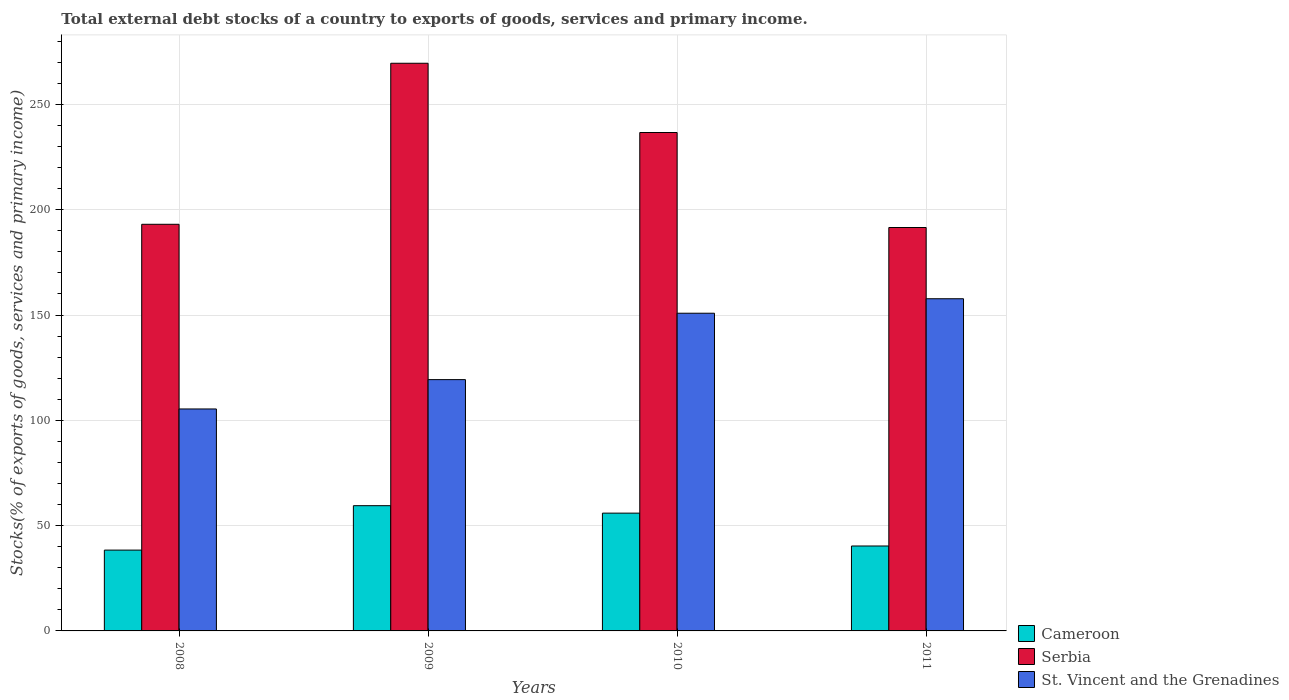How many groups of bars are there?
Your answer should be very brief. 4. Are the number of bars on each tick of the X-axis equal?
Provide a short and direct response. Yes. How many bars are there on the 2nd tick from the left?
Offer a very short reply. 3. What is the total debt stocks in Serbia in 2011?
Provide a short and direct response. 191.56. Across all years, what is the maximum total debt stocks in St. Vincent and the Grenadines?
Keep it short and to the point. 157.74. Across all years, what is the minimum total debt stocks in St. Vincent and the Grenadines?
Offer a very short reply. 105.4. In which year was the total debt stocks in St. Vincent and the Grenadines maximum?
Make the answer very short. 2011. What is the total total debt stocks in Cameroon in the graph?
Provide a short and direct response. 194.1. What is the difference between the total debt stocks in St. Vincent and the Grenadines in 2008 and that in 2010?
Make the answer very short. -45.46. What is the difference between the total debt stocks in St. Vincent and the Grenadines in 2008 and the total debt stocks in Cameroon in 2010?
Offer a very short reply. 49.47. What is the average total debt stocks in St. Vincent and the Grenadines per year?
Provide a succinct answer. 133.33. In the year 2008, what is the difference between the total debt stocks in Serbia and total debt stocks in Cameroon?
Your answer should be very brief. 154.71. What is the ratio of the total debt stocks in Cameroon in 2010 to that in 2011?
Give a very brief answer. 1.39. What is the difference between the highest and the second highest total debt stocks in Serbia?
Make the answer very short. 32.89. What is the difference between the highest and the lowest total debt stocks in Cameroon?
Your response must be concise. 21.09. What does the 1st bar from the left in 2009 represents?
Give a very brief answer. Cameroon. What does the 2nd bar from the right in 2008 represents?
Ensure brevity in your answer.  Serbia. Is it the case that in every year, the sum of the total debt stocks in Cameroon and total debt stocks in Serbia is greater than the total debt stocks in St. Vincent and the Grenadines?
Offer a terse response. Yes. How many bars are there?
Offer a terse response. 12. What is the difference between two consecutive major ticks on the Y-axis?
Offer a very short reply. 50. Are the values on the major ticks of Y-axis written in scientific E-notation?
Keep it short and to the point. No. Does the graph contain grids?
Keep it short and to the point. Yes. Where does the legend appear in the graph?
Your response must be concise. Bottom right. How many legend labels are there?
Provide a short and direct response. 3. What is the title of the graph?
Offer a terse response. Total external debt stocks of a country to exports of goods, services and primary income. Does "Kazakhstan" appear as one of the legend labels in the graph?
Your answer should be very brief. No. What is the label or title of the X-axis?
Give a very brief answer. Years. What is the label or title of the Y-axis?
Offer a terse response. Stocks(% of exports of goods, services and primary income). What is the Stocks(% of exports of goods, services and primary income) of Cameroon in 2008?
Your answer should be compact. 38.38. What is the Stocks(% of exports of goods, services and primary income) of Serbia in 2008?
Make the answer very short. 193.09. What is the Stocks(% of exports of goods, services and primary income) in St. Vincent and the Grenadines in 2008?
Provide a short and direct response. 105.4. What is the Stocks(% of exports of goods, services and primary income) in Cameroon in 2009?
Your answer should be very brief. 59.47. What is the Stocks(% of exports of goods, services and primary income) of Serbia in 2009?
Your response must be concise. 269.55. What is the Stocks(% of exports of goods, services and primary income) in St. Vincent and the Grenadines in 2009?
Ensure brevity in your answer.  119.33. What is the Stocks(% of exports of goods, services and primary income) of Cameroon in 2010?
Your answer should be compact. 55.93. What is the Stocks(% of exports of goods, services and primary income) in Serbia in 2010?
Give a very brief answer. 236.67. What is the Stocks(% of exports of goods, services and primary income) in St. Vincent and the Grenadines in 2010?
Your answer should be very brief. 150.85. What is the Stocks(% of exports of goods, services and primary income) in Cameroon in 2011?
Offer a very short reply. 40.33. What is the Stocks(% of exports of goods, services and primary income) of Serbia in 2011?
Give a very brief answer. 191.56. What is the Stocks(% of exports of goods, services and primary income) of St. Vincent and the Grenadines in 2011?
Keep it short and to the point. 157.74. Across all years, what is the maximum Stocks(% of exports of goods, services and primary income) of Cameroon?
Ensure brevity in your answer.  59.47. Across all years, what is the maximum Stocks(% of exports of goods, services and primary income) in Serbia?
Ensure brevity in your answer.  269.55. Across all years, what is the maximum Stocks(% of exports of goods, services and primary income) in St. Vincent and the Grenadines?
Give a very brief answer. 157.74. Across all years, what is the minimum Stocks(% of exports of goods, services and primary income) in Cameroon?
Your response must be concise. 38.38. Across all years, what is the minimum Stocks(% of exports of goods, services and primary income) in Serbia?
Provide a short and direct response. 191.56. Across all years, what is the minimum Stocks(% of exports of goods, services and primary income) of St. Vincent and the Grenadines?
Ensure brevity in your answer.  105.4. What is the total Stocks(% of exports of goods, services and primary income) of Cameroon in the graph?
Your answer should be compact. 194.1. What is the total Stocks(% of exports of goods, services and primary income) in Serbia in the graph?
Ensure brevity in your answer.  890.87. What is the total Stocks(% of exports of goods, services and primary income) of St. Vincent and the Grenadines in the graph?
Provide a short and direct response. 533.32. What is the difference between the Stocks(% of exports of goods, services and primary income) in Cameroon in 2008 and that in 2009?
Ensure brevity in your answer.  -21.09. What is the difference between the Stocks(% of exports of goods, services and primary income) of Serbia in 2008 and that in 2009?
Your answer should be compact. -76.47. What is the difference between the Stocks(% of exports of goods, services and primary income) of St. Vincent and the Grenadines in 2008 and that in 2009?
Give a very brief answer. -13.93. What is the difference between the Stocks(% of exports of goods, services and primary income) of Cameroon in 2008 and that in 2010?
Make the answer very short. -17.55. What is the difference between the Stocks(% of exports of goods, services and primary income) in Serbia in 2008 and that in 2010?
Your answer should be compact. -43.58. What is the difference between the Stocks(% of exports of goods, services and primary income) of St. Vincent and the Grenadines in 2008 and that in 2010?
Your response must be concise. -45.46. What is the difference between the Stocks(% of exports of goods, services and primary income) in Cameroon in 2008 and that in 2011?
Your answer should be very brief. -1.95. What is the difference between the Stocks(% of exports of goods, services and primary income) in Serbia in 2008 and that in 2011?
Provide a short and direct response. 1.53. What is the difference between the Stocks(% of exports of goods, services and primary income) in St. Vincent and the Grenadines in 2008 and that in 2011?
Give a very brief answer. -52.34. What is the difference between the Stocks(% of exports of goods, services and primary income) in Cameroon in 2009 and that in 2010?
Your answer should be compact. 3.54. What is the difference between the Stocks(% of exports of goods, services and primary income) in Serbia in 2009 and that in 2010?
Give a very brief answer. 32.89. What is the difference between the Stocks(% of exports of goods, services and primary income) in St. Vincent and the Grenadines in 2009 and that in 2010?
Provide a short and direct response. -31.52. What is the difference between the Stocks(% of exports of goods, services and primary income) in Cameroon in 2009 and that in 2011?
Give a very brief answer. 19.14. What is the difference between the Stocks(% of exports of goods, services and primary income) of Serbia in 2009 and that in 2011?
Provide a short and direct response. 77.99. What is the difference between the Stocks(% of exports of goods, services and primary income) in St. Vincent and the Grenadines in 2009 and that in 2011?
Provide a short and direct response. -38.41. What is the difference between the Stocks(% of exports of goods, services and primary income) in Cameroon in 2010 and that in 2011?
Offer a terse response. 15.6. What is the difference between the Stocks(% of exports of goods, services and primary income) in Serbia in 2010 and that in 2011?
Make the answer very short. 45.11. What is the difference between the Stocks(% of exports of goods, services and primary income) in St. Vincent and the Grenadines in 2010 and that in 2011?
Offer a terse response. -6.88. What is the difference between the Stocks(% of exports of goods, services and primary income) of Cameroon in 2008 and the Stocks(% of exports of goods, services and primary income) of Serbia in 2009?
Your answer should be compact. -231.18. What is the difference between the Stocks(% of exports of goods, services and primary income) of Cameroon in 2008 and the Stocks(% of exports of goods, services and primary income) of St. Vincent and the Grenadines in 2009?
Offer a terse response. -80.95. What is the difference between the Stocks(% of exports of goods, services and primary income) in Serbia in 2008 and the Stocks(% of exports of goods, services and primary income) in St. Vincent and the Grenadines in 2009?
Offer a terse response. 73.76. What is the difference between the Stocks(% of exports of goods, services and primary income) of Cameroon in 2008 and the Stocks(% of exports of goods, services and primary income) of Serbia in 2010?
Ensure brevity in your answer.  -198.29. What is the difference between the Stocks(% of exports of goods, services and primary income) of Cameroon in 2008 and the Stocks(% of exports of goods, services and primary income) of St. Vincent and the Grenadines in 2010?
Give a very brief answer. -112.48. What is the difference between the Stocks(% of exports of goods, services and primary income) in Serbia in 2008 and the Stocks(% of exports of goods, services and primary income) in St. Vincent and the Grenadines in 2010?
Offer a terse response. 42.23. What is the difference between the Stocks(% of exports of goods, services and primary income) in Cameroon in 2008 and the Stocks(% of exports of goods, services and primary income) in Serbia in 2011?
Offer a very short reply. -153.18. What is the difference between the Stocks(% of exports of goods, services and primary income) of Cameroon in 2008 and the Stocks(% of exports of goods, services and primary income) of St. Vincent and the Grenadines in 2011?
Offer a very short reply. -119.36. What is the difference between the Stocks(% of exports of goods, services and primary income) in Serbia in 2008 and the Stocks(% of exports of goods, services and primary income) in St. Vincent and the Grenadines in 2011?
Your response must be concise. 35.35. What is the difference between the Stocks(% of exports of goods, services and primary income) of Cameroon in 2009 and the Stocks(% of exports of goods, services and primary income) of Serbia in 2010?
Provide a succinct answer. -177.2. What is the difference between the Stocks(% of exports of goods, services and primary income) of Cameroon in 2009 and the Stocks(% of exports of goods, services and primary income) of St. Vincent and the Grenadines in 2010?
Offer a terse response. -91.39. What is the difference between the Stocks(% of exports of goods, services and primary income) in Serbia in 2009 and the Stocks(% of exports of goods, services and primary income) in St. Vincent and the Grenadines in 2010?
Give a very brief answer. 118.7. What is the difference between the Stocks(% of exports of goods, services and primary income) of Cameroon in 2009 and the Stocks(% of exports of goods, services and primary income) of Serbia in 2011?
Make the answer very short. -132.09. What is the difference between the Stocks(% of exports of goods, services and primary income) in Cameroon in 2009 and the Stocks(% of exports of goods, services and primary income) in St. Vincent and the Grenadines in 2011?
Make the answer very short. -98.27. What is the difference between the Stocks(% of exports of goods, services and primary income) in Serbia in 2009 and the Stocks(% of exports of goods, services and primary income) in St. Vincent and the Grenadines in 2011?
Offer a very short reply. 111.82. What is the difference between the Stocks(% of exports of goods, services and primary income) in Cameroon in 2010 and the Stocks(% of exports of goods, services and primary income) in Serbia in 2011?
Make the answer very short. -135.63. What is the difference between the Stocks(% of exports of goods, services and primary income) in Cameroon in 2010 and the Stocks(% of exports of goods, services and primary income) in St. Vincent and the Grenadines in 2011?
Give a very brief answer. -101.81. What is the difference between the Stocks(% of exports of goods, services and primary income) of Serbia in 2010 and the Stocks(% of exports of goods, services and primary income) of St. Vincent and the Grenadines in 2011?
Your answer should be very brief. 78.93. What is the average Stocks(% of exports of goods, services and primary income) of Cameroon per year?
Your response must be concise. 48.53. What is the average Stocks(% of exports of goods, services and primary income) in Serbia per year?
Your answer should be compact. 222.72. What is the average Stocks(% of exports of goods, services and primary income) in St. Vincent and the Grenadines per year?
Offer a terse response. 133.33. In the year 2008, what is the difference between the Stocks(% of exports of goods, services and primary income) in Cameroon and Stocks(% of exports of goods, services and primary income) in Serbia?
Make the answer very short. -154.71. In the year 2008, what is the difference between the Stocks(% of exports of goods, services and primary income) in Cameroon and Stocks(% of exports of goods, services and primary income) in St. Vincent and the Grenadines?
Ensure brevity in your answer.  -67.02. In the year 2008, what is the difference between the Stocks(% of exports of goods, services and primary income) in Serbia and Stocks(% of exports of goods, services and primary income) in St. Vincent and the Grenadines?
Provide a short and direct response. 87.69. In the year 2009, what is the difference between the Stocks(% of exports of goods, services and primary income) in Cameroon and Stocks(% of exports of goods, services and primary income) in Serbia?
Keep it short and to the point. -210.09. In the year 2009, what is the difference between the Stocks(% of exports of goods, services and primary income) of Cameroon and Stocks(% of exports of goods, services and primary income) of St. Vincent and the Grenadines?
Offer a very short reply. -59.86. In the year 2009, what is the difference between the Stocks(% of exports of goods, services and primary income) of Serbia and Stocks(% of exports of goods, services and primary income) of St. Vincent and the Grenadines?
Your response must be concise. 150.22. In the year 2010, what is the difference between the Stocks(% of exports of goods, services and primary income) of Cameroon and Stocks(% of exports of goods, services and primary income) of Serbia?
Ensure brevity in your answer.  -180.74. In the year 2010, what is the difference between the Stocks(% of exports of goods, services and primary income) in Cameroon and Stocks(% of exports of goods, services and primary income) in St. Vincent and the Grenadines?
Give a very brief answer. -94.92. In the year 2010, what is the difference between the Stocks(% of exports of goods, services and primary income) in Serbia and Stocks(% of exports of goods, services and primary income) in St. Vincent and the Grenadines?
Your answer should be very brief. 85.81. In the year 2011, what is the difference between the Stocks(% of exports of goods, services and primary income) of Cameroon and Stocks(% of exports of goods, services and primary income) of Serbia?
Offer a terse response. -151.23. In the year 2011, what is the difference between the Stocks(% of exports of goods, services and primary income) of Cameroon and Stocks(% of exports of goods, services and primary income) of St. Vincent and the Grenadines?
Offer a very short reply. -117.41. In the year 2011, what is the difference between the Stocks(% of exports of goods, services and primary income) of Serbia and Stocks(% of exports of goods, services and primary income) of St. Vincent and the Grenadines?
Ensure brevity in your answer.  33.82. What is the ratio of the Stocks(% of exports of goods, services and primary income) in Cameroon in 2008 to that in 2009?
Offer a terse response. 0.65. What is the ratio of the Stocks(% of exports of goods, services and primary income) in Serbia in 2008 to that in 2009?
Provide a short and direct response. 0.72. What is the ratio of the Stocks(% of exports of goods, services and primary income) of St. Vincent and the Grenadines in 2008 to that in 2009?
Your answer should be compact. 0.88. What is the ratio of the Stocks(% of exports of goods, services and primary income) in Cameroon in 2008 to that in 2010?
Ensure brevity in your answer.  0.69. What is the ratio of the Stocks(% of exports of goods, services and primary income) in Serbia in 2008 to that in 2010?
Your answer should be very brief. 0.82. What is the ratio of the Stocks(% of exports of goods, services and primary income) of St. Vincent and the Grenadines in 2008 to that in 2010?
Your response must be concise. 0.7. What is the ratio of the Stocks(% of exports of goods, services and primary income) of Cameroon in 2008 to that in 2011?
Ensure brevity in your answer.  0.95. What is the ratio of the Stocks(% of exports of goods, services and primary income) in St. Vincent and the Grenadines in 2008 to that in 2011?
Your answer should be very brief. 0.67. What is the ratio of the Stocks(% of exports of goods, services and primary income) of Cameroon in 2009 to that in 2010?
Give a very brief answer. 1.06. What is the ratio of the Stocks(% of exports of goods, services and primary income) of Serbia in 2009 to that in 2010?
Ensure brevity in your answer.  1.14. What is the ratio of the Stocks(% of exports of goods, services and primary income) of St. Vincent and the Grenadines in 2009 to that in 2010?
Your answer should be compact. 0.79. What is the ratio of the Stocks(% of exports of goods, services and primary income) of Cameroon in 2009 to that in 2011?
Your answer should be very brief. 1.47. What is the ratio of the Stocks(% of exports of goods, services and primary income) of Serbia in 2009 to that in 2011?
Keep it short and to the point. 1.41. What is the ratio of the Stocks(% of exports of goods, services and primary income) of St. Vincent and the Grenadines in 2009 to that in 2011?
Offer a terse response. 0.76. What is the ratio of the Stocks(% of exports of goods, services and primary income) in Cameroon in 2010 to that in 2011?
Keep it short and to the point. 1.39. What is the ratio of the Stocks(% of exports of goods, services and primary income) in Serbia in 2010 to that in 2011?
Make the answer very short. 1.24. What is the ratio of the Stocks(% of exports of goods, services and primary income) in St. Vincent and the Grenadines in 2010 to that in 2011?
Make the answer very short. 0.96. What is the difference between the highest and the second highest Stocks(% of exports of goods, services and primary income) of Cameroon?
Your answer should be very brief. 3.54. What is the difference between the highest and the second highest Stocks(% of exports of goods, services and primary income) of Serbia?
Your response must be concise. 32.89. What is the difference between the highest and the second highest Stocks(% of exports of goods, services and primary income) in St. Vincent and the Grenadines?
Make the answer very short. 6.88. What is the difference between the highest and the lowest Stocks(% of exports of goods, services and primary income) of Cameroon?
Offer a very short reply. 21.09. What is the difference between the highest and the lowest Stocks(% of exports of goods, services and primary income) of Serbia?
Your response must be concise. 77.99. What is the difference between the highest and the lowest Stocks(% of exports of goods, services and primary income) of St. Vincent and the Grenadines?
Keep it short and to the point. 52.34. 